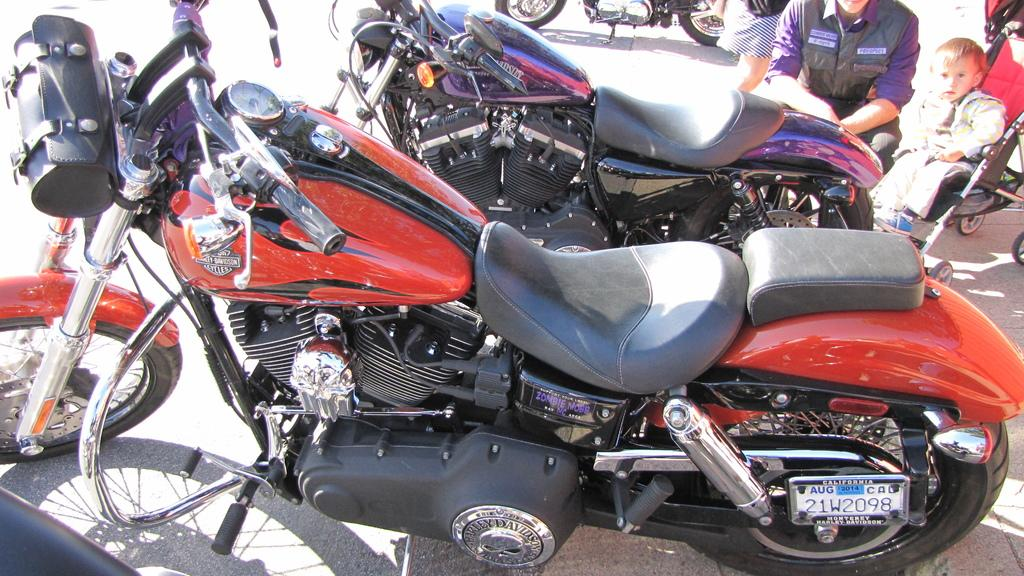What type of vehicles are present in the image? There are bikes in the image. Can you identify any people in the image? Yes, there are people in the top right corner of the image. What else can be seen in the image besides bikes and people? There is a kid in a stroller. What type of van can be seen in the image? There is no van present in the image. What event is taking place in the image? The image does not depict a specific event; it simply shows bikes, people, and a kid in a stroller. 